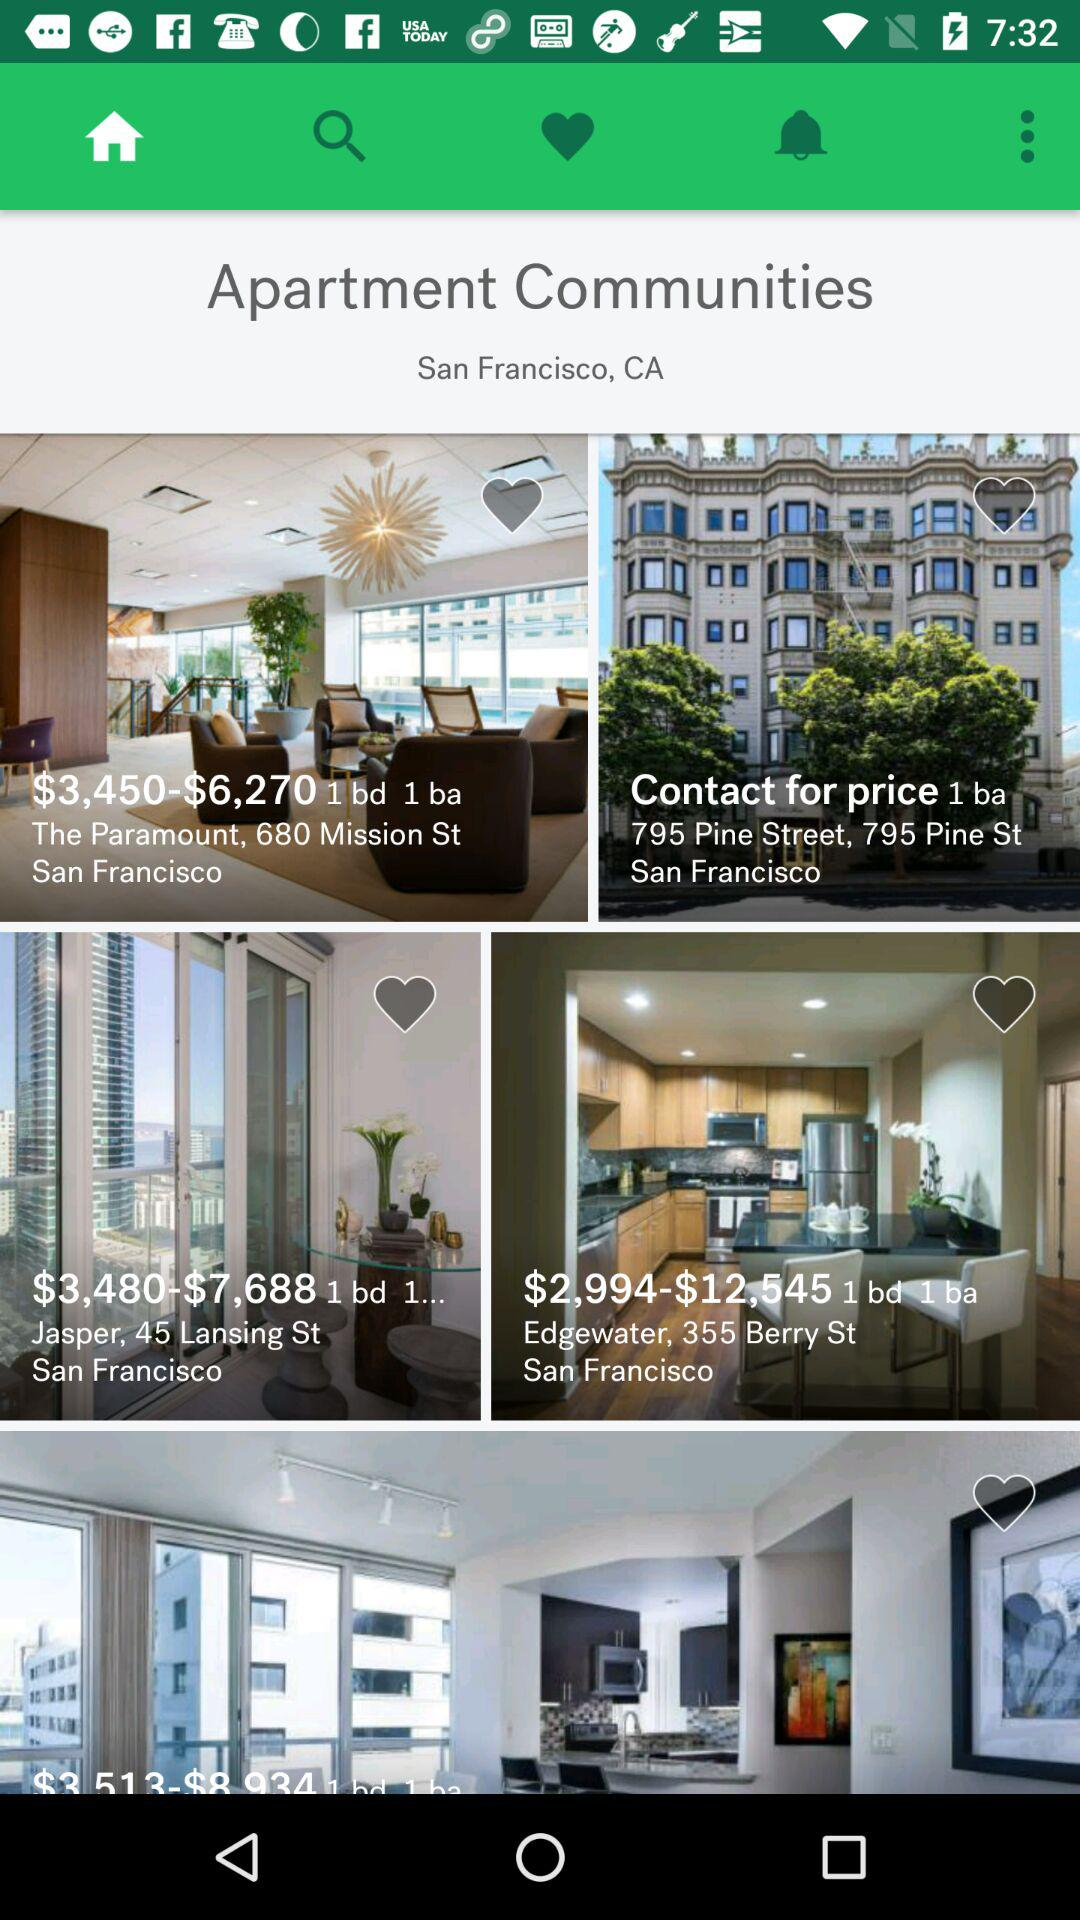Which tab is currently selected? The currently selected tab is "Home". 